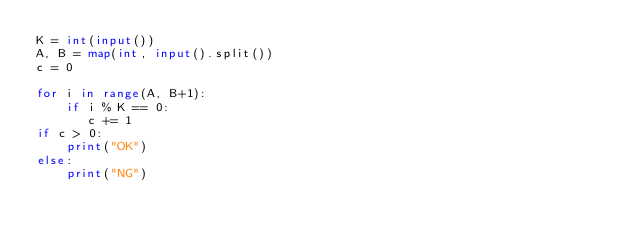Convert code to text. <code><loc_0><loc_0><loc_500><loc_500><_Python_>K = int(input())
A, B = map(int, input().split())
c = 0

for i in range(A, B+1):
    if i % K == 0:
       c += 1
if c > 0:
    print("OK")
else:
    print("NG")</code> 